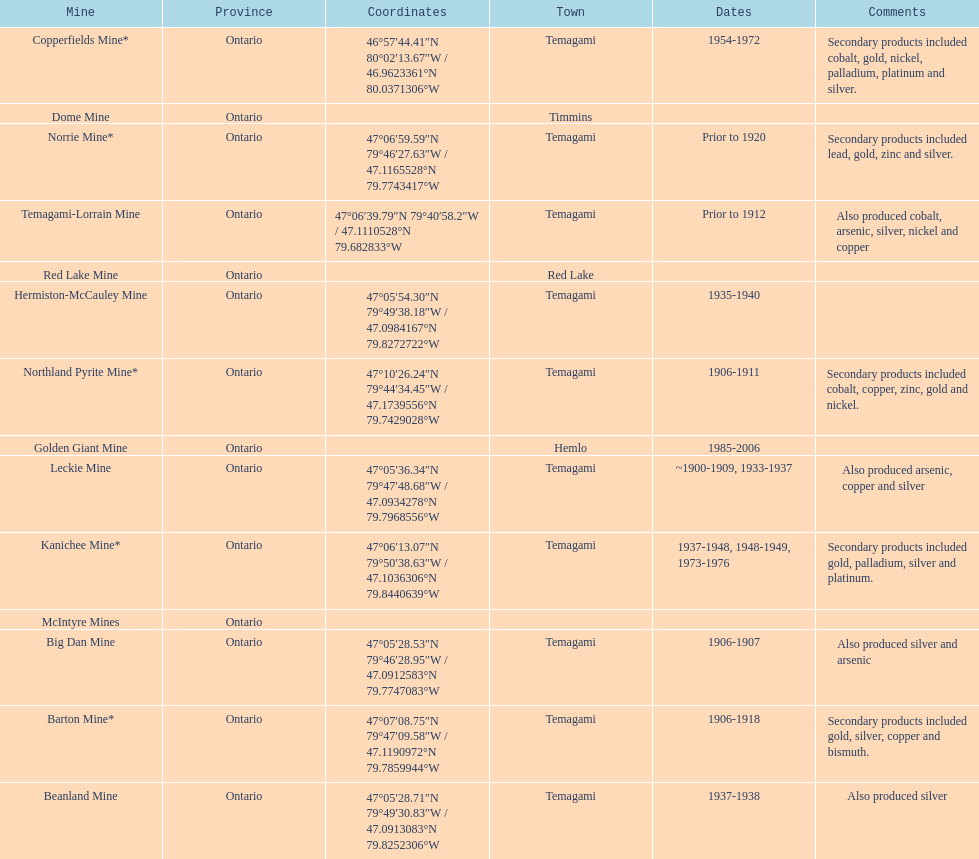Tell me the number of mines that also produced arsenic. 3. 